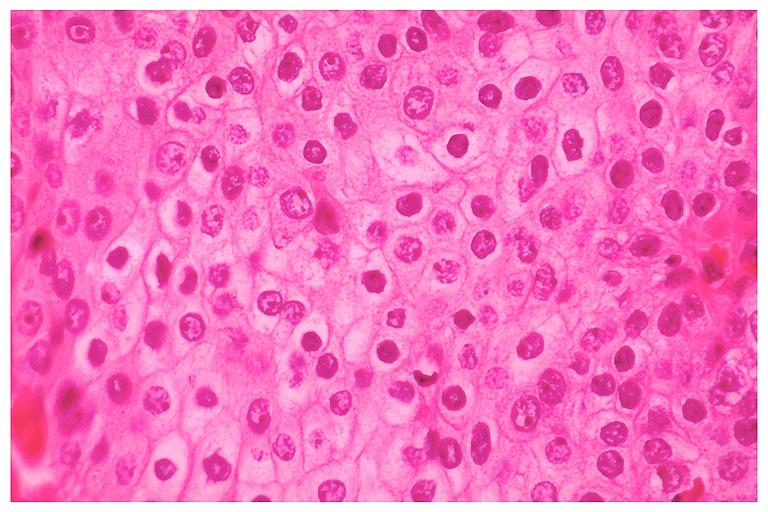s natural color present?
Answer the question using a single word or phrase. No 